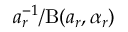Convert formula to latex. <formula><loc_0><loc_0><loc_500><loc_500>a _ { r } ^ { - 1 } / B ( a _ { r } , \alpha _ { r } )</formula> 